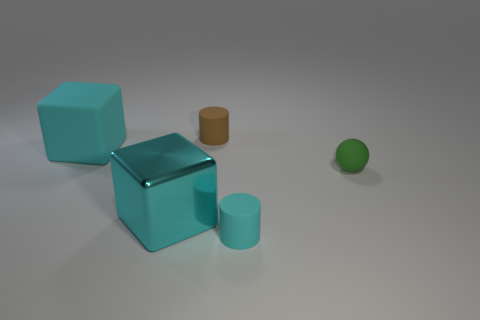Add 3 big blue metal balls. How many objects exist? 8 Subtract all spheres. How many objects are left? 4 Subtract 0 cyan spheres. How many objects are left? 5 Subtract all big cubes. Subtract all tiny cyan matte cylinders. How many objects are left? 2 Add 2 cyan cylinders. How many cyan cylinders are left? 3 Add 1 big matte blocks. How many big matte blocks exist? 2 